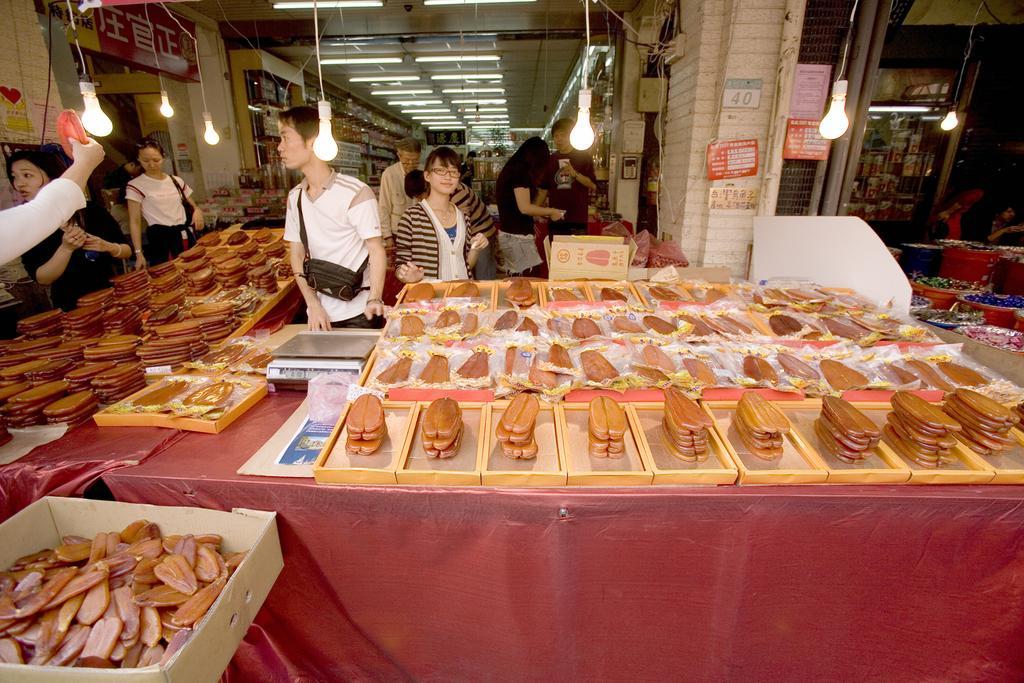Could you give a brief overview of what you see in this image? In this picture we can see some people, bags, boxes, trays on tables, posters, pipes, wall and some objects and in the background we can see the lights, ceiling. 